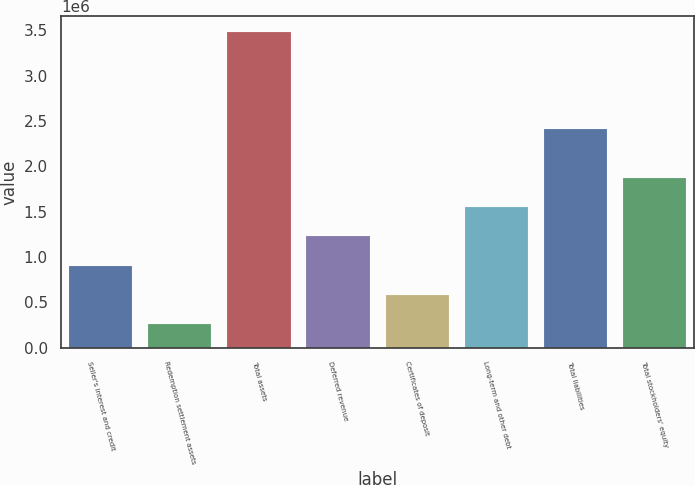<chart> <loc_0><loc_0><loc_500><loc_500><bar_chart><fcel>Seller's interest and credit<fcel>Redemption settlement assets<fcel>Total assets<fcel>Deferred revenue<fcel>Certificates of deposit<fcel>Long-term and other debt<fcel>Total liabilities<fcel>Total stockholders' equity<nl><fcel>905005<fcel>260957<fcel>3.4812e+06<fcel>1.22703e+06<fcel>582981<fcel>1.54905e+06<fcel>2.40967e+06<fcel>1.87108e+06<nl></chart> 